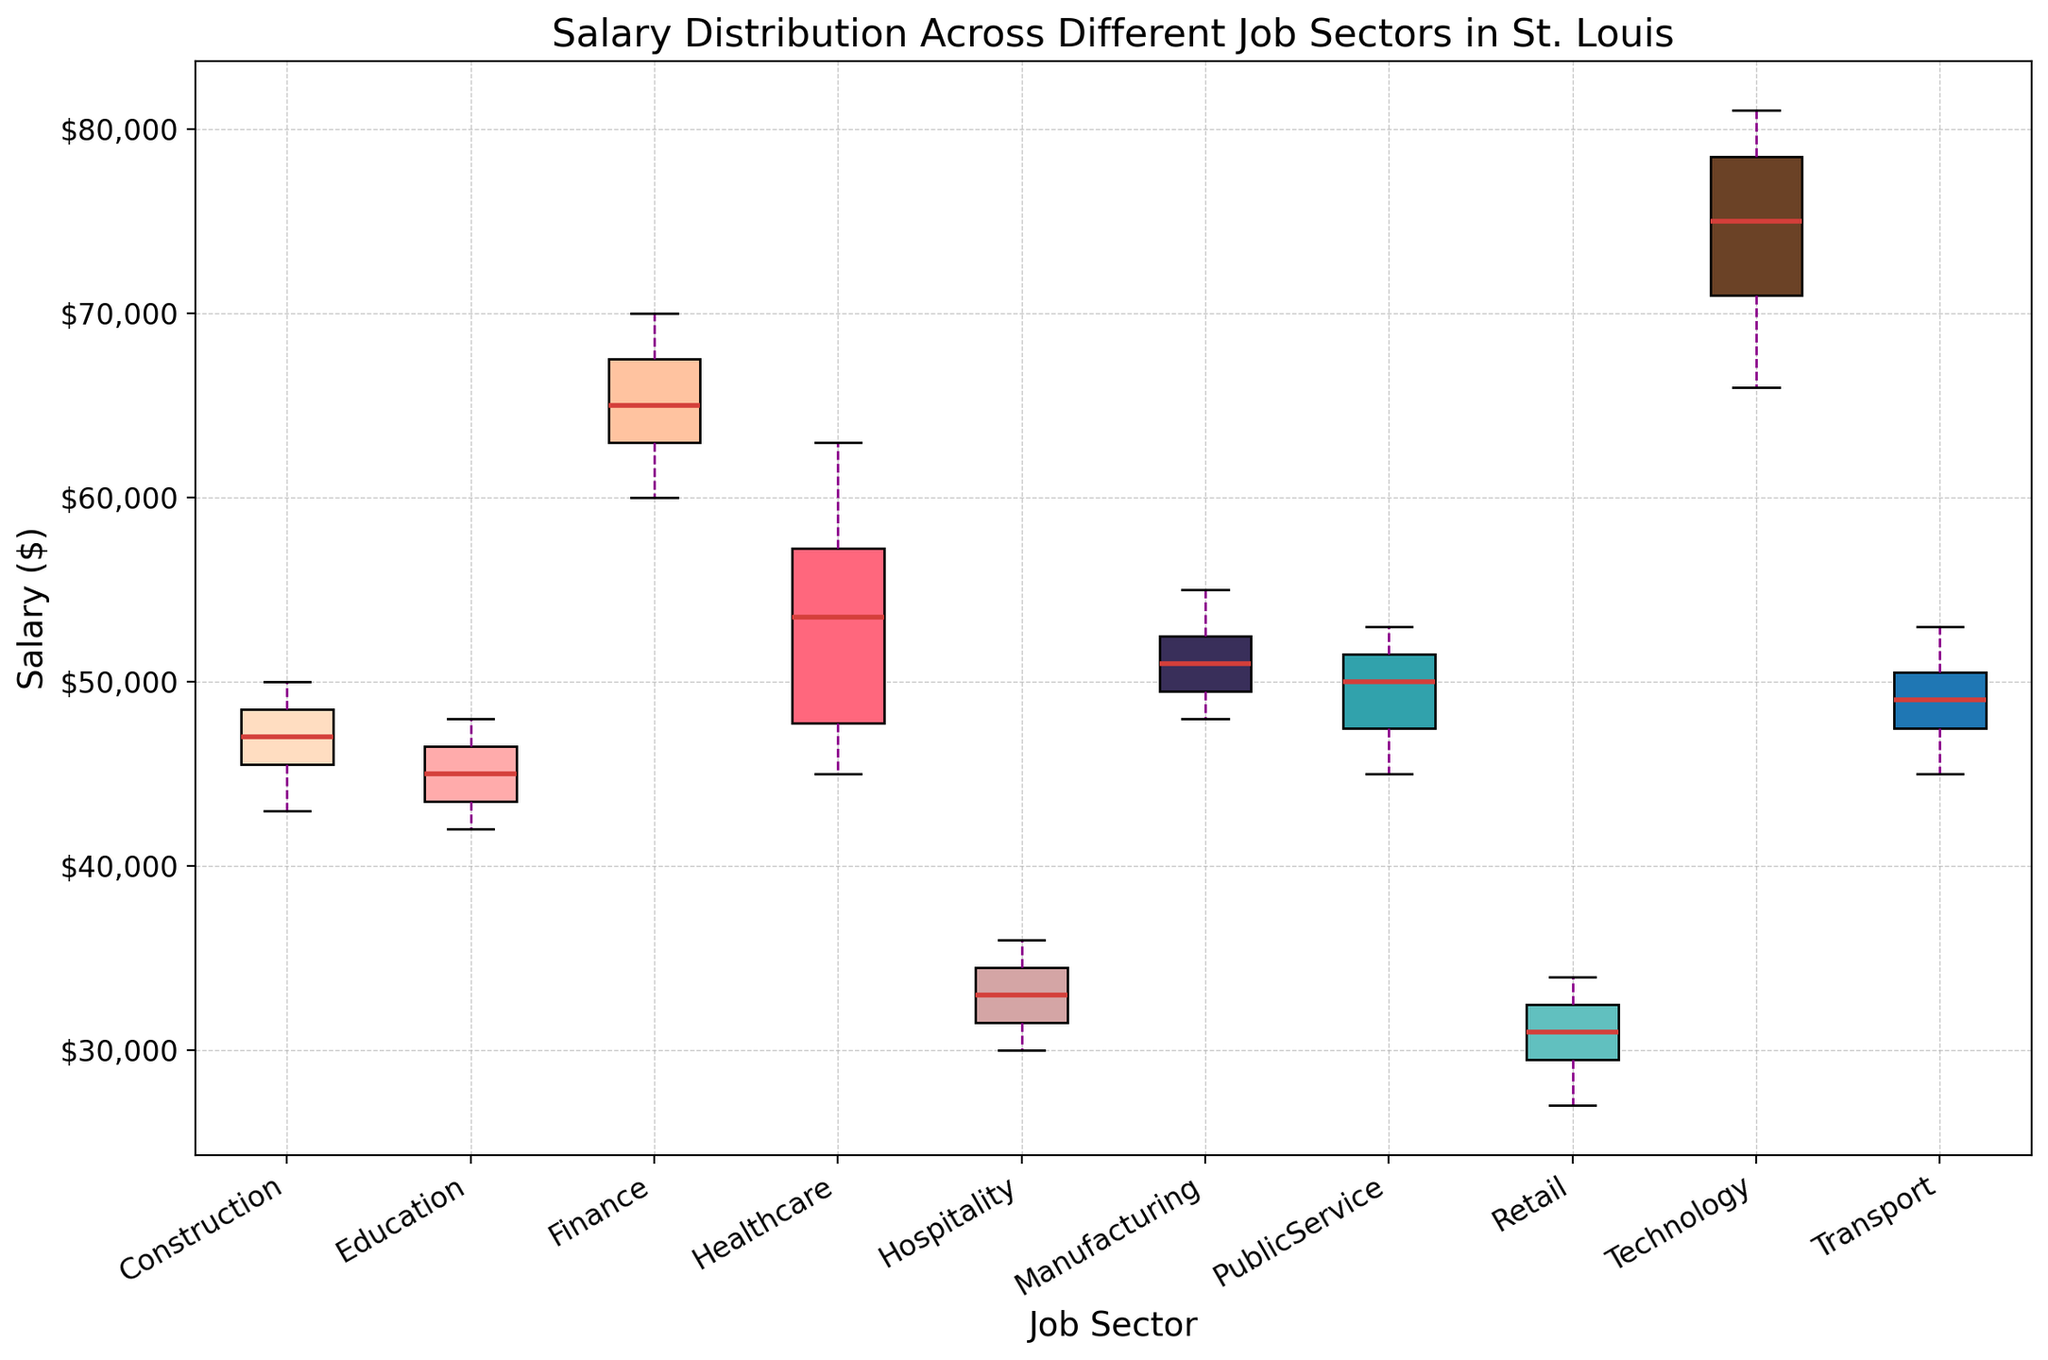Which job sector has the highest median salary? To find the highest median salary, look at the median line inside each boxplot. The Technology sector's boxplot has the highest median line compared to other sectors.
Answer: Technology What is the interquartile range (IQR) for the Healthcare sector? The interquartile range is the difference between the upper quartile (75th percentile) and the lower quartile (25th percentile). For Healthcare, estimate these values from the box edges and subtract the lower from the upper.
Answer: $18,000 How does the median salary in the Finance sector compare to that in the Manufacturing sector? Compare the median lines in the boxplots for the Finance and Manufacturing sectors. The Finance sector has a higher median salary than the Manufacturing sector.
Answer: Finance is higher Which job sector has the smallest range of salaries? The range is the difference between the maximum and minimum values (whiskers) in the boxplot. The Construction sector's boxplot is the shortest, indicating the smallest range.
Answer: Construction Is there any sector where the minimum salary is above $30,000? Examine the lowest whisker point in each boxplot. Sectors like Technology, Finance, and Public Service have minimum salaries above $30,000.
Answer: Yes, Technology, Finance, and Public Service What is the median salary difference between Technology and Retail sectors? Identify the median lines in the boxplots for Technology and Retail, then subtract the Retail median from the Technology median to find the difference.
Answer: $43,000 Which sector has the highest variability in salaries? The sector with the longest distance between the whiskers (max-min) has the highest variability. The Technology sector's whiskers span the widest range, indicating high variability.
Answer: Technology How do the upper quartile salaries of Education and Healthcare compare? Compare the top edges of the boxes for Education and Healthcare. The upper quartile for Healthcare is higher than for Education.
Answer: Healthcare is higher What colors are used to represent the Education and Retail sectors? Visual inspection of the box plots reveals the colors. The Education sector is colored in a shade of pink, while the Retail sector is in a light orange shade.
Answer: Pink for Education, Light orange for Retail How does the highest salary in the Manufacturing sector compare to that in the Transport sector? Look at the top whiskers for both sectors. The highest salary in Manufacturing is slightly lower than the highest in Transport.
Answer: Transport is higher 